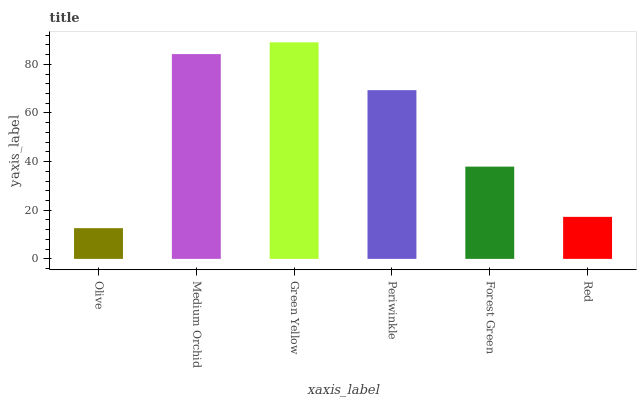Is Olive the minimum?
Answer yes or no. Yes. Is Green Yellow the maximum?
Answer yes or no. Yes. Is Medium Orchid the minimum?
Answer yes or no. No. Is Medium Orchid the maximum?
Answer yes or no. No. Is Medium Orchid greater than Olive?
Answer yes or no. Yes. Is Olive less than Medium Orchid?
Answer yes or no. Yes. Is Olive greater than Medium Orchid?
Answer yes or no. No. Is Medium Orchid less than Olive?
Answer yes or no. No. Is Periwinkle the high median?
Answer yes or no. Yes. Is Forest Green the low median?
Answer yes or no. Yes. Is Forest Green the high median?
Answer yes or no. No. Is Periwinkle the low median?
Answer yes or no. No. 